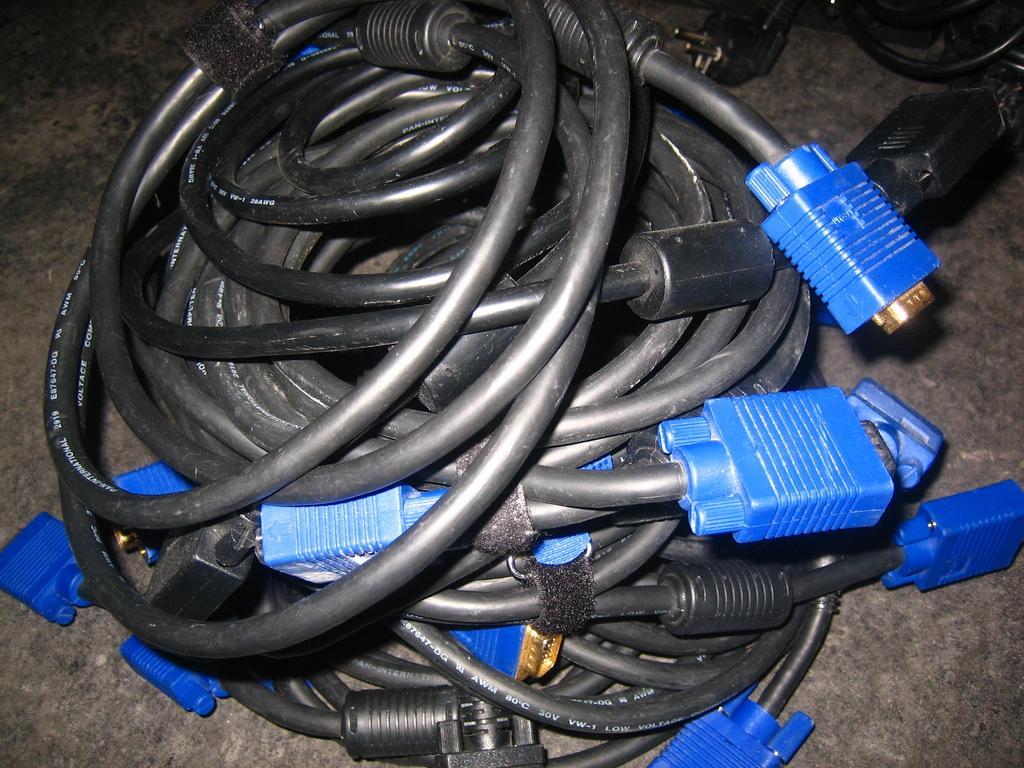How would you summarize this image in a sentence or two? In this image we can see wires which are black color and there are some plants which are in blue color. 